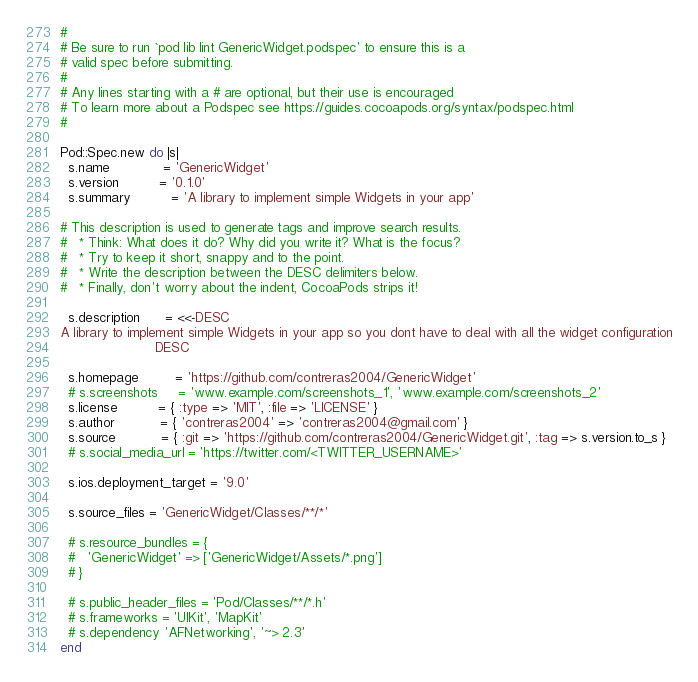<code> <loc_0><loc_0><loc_500><loc_500><_Ruby_>#
# Be sure to run `pod lib lint GenericWidget.podspec' to ensure this is a
# valid spec before submitting.
#
# Any lines starting with a # are optional, but their use is encouraged
# To learn more about a Podspec see https://guides.cocoapods.org/syntax/podspec.html
#

Pod::Spec.new do |s|
  s.name             = 'GenericWidget'
  s.version          = '0.1.0'
  s.summary          = 'A library to implement simple Widgets in your app'

# This description is used to generate tags and improve search results.
#   * Think: What does it do? Why did you write it? What is the focus?
#   * Try to keep it short, snappy and to the point.
#   * Write the description between the DESC delimiters below.
#   * Finally, don't worry about the indent, CocoaPods strips it!

  s.description      = <<-DESC
A library to implement simple Widgets in your app so you dont have to deal with all the widget configuration
                       DESC

  s.homepage         = 'https://github.com/contreras2004/GenericWidget'
  # s.screenshots     = 'www.example.com/screenshots_1', 'www.example.com/screenshots_2'
  s.license          = { :type => 'MIT', :file => 'LICENSE' }
  s.author           = { 'contreras2004' => 'contreras2004@gmail.com' }
  s.source           = { :git => 'https://github.com/contreras2004/GenericWidget.git', :tag => s.version.to_s }
  # s.social_media_url = 'https://twitter.com/<TWITTER_USERNAME>'

  s.ios.deployment_target = '9.0'

  s.source_files = 'GenericWidget/Classes/**/*'
  
  # s.resource_bundles = {
  #   'GenericWidget' => ['GenericWidget/Assets/*.png']
  # }

  # s.public_header_files = 'Pod/Classes/**/*.h'
  # s.frameworks = 'UIKit', 'MapKit'
  # s.dependency 'AFNetworking', '~> 2.3'
end
</code> 